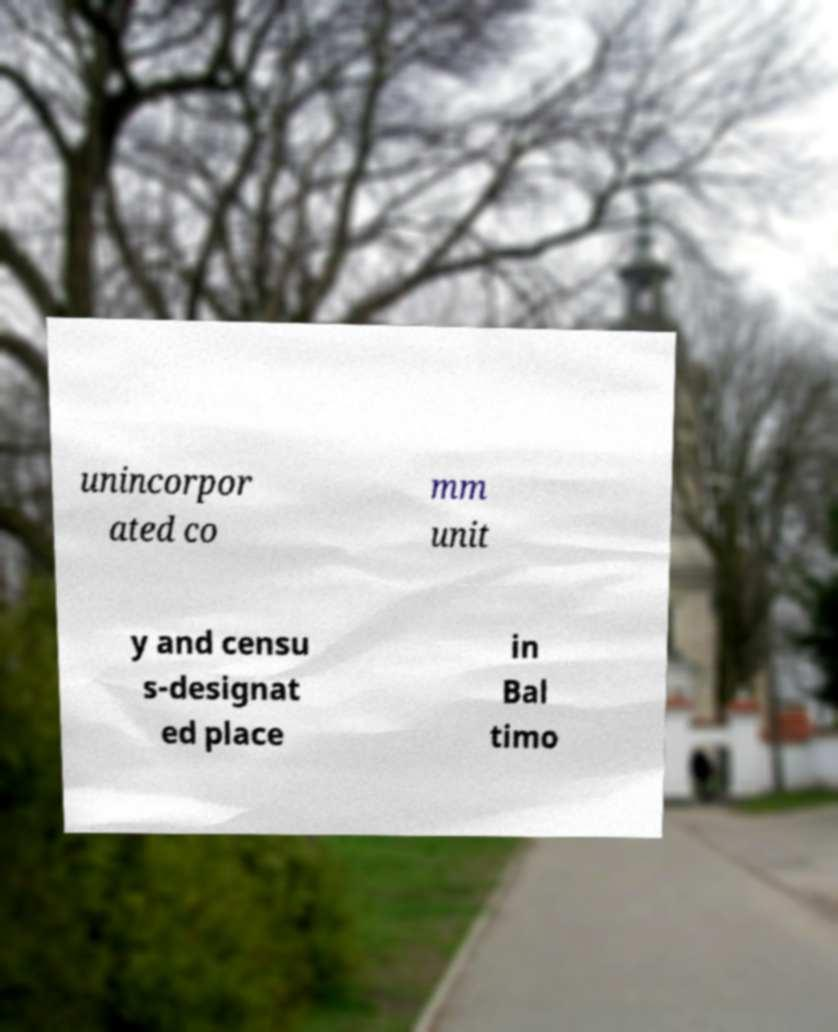Could you extract and type out the text from this image? unincorpor ated co mm unit y and censu s-designat ed place in Bal timo 